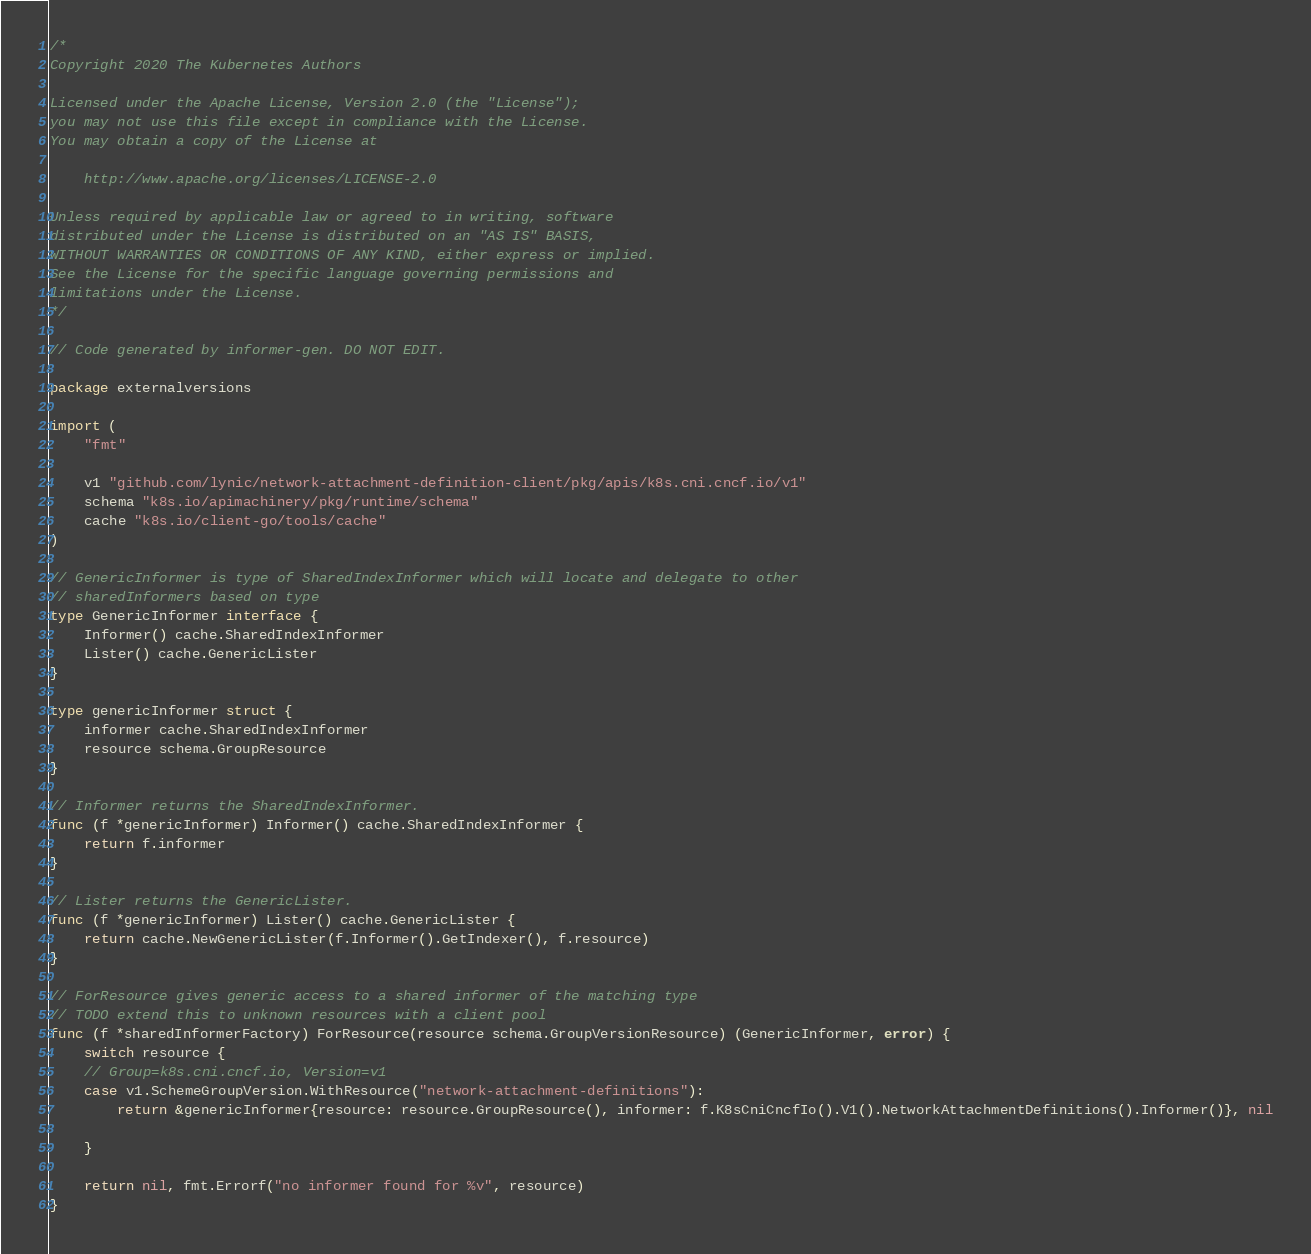Convert code to text. <code><loc_0><loc_0><loc_500><loc_500><_Go_>/*
Copyright 2020 The Kubernetes Authors

Licensed under the Apache License, Version 2.0 (the "License");
you may not use this file except in compliance with the License.
You may obtain a copy of the License at

    http://www.apache.org/licenses/LICENSE-2.0

Unless required by applicable law or agreed to in writing, software
distributed under the License is distributed on an "AS IS" BASIS,
WITHOUT WARRANTIES OR CONDITIONS OF ANY KIND, either express or implied.
See the License for the specific language governing permissions and
limitations under the License.
*/

// Code generated by informer-gen. DO NOT EDIT.

package externalversions

import (
	"fmt"

	v1 "github.com/lynic/network-attachment-definition-client/pkg/apis/k8s.cni.cncf.io/v1"
	schema "k8s.io/apimachinery/pkg/runtime/schema"
	cache "k8s.io/client-go/tools/cache"
)

// GenericInformer is type of SharedIndexInformer which will locate and delegate to other
// sharedInformers based on type
type GenericInformer interface {
	Informer() cache.SharedIndexInformer
	Lister() cache.GenericLister
}

type genericInformer struct {
	informer cache.SharedIndexInformer
	resource schema.GroupResource
}

// Informer returns the SharedIndexInformer.
func (f *genericInformer) Informer() cache.SharedIndexInformer {
	return f.informer
}

// Lister returns the GenericLister.
func (f *genericInformer) Lister() cache.GenericLister {
	return cache.NewGenericLister(f.Informer().GetIndexer(), f.resource)
}

// ForResource gives generic access to a shared informer of the matching type
// TODO extend this to unknown resources with a client pool
func (f *sharedInformerFactory) ForResource(resource schema.GroupVersionResource) (GenericInformer, error) {
	switch resource {
	// Group=k8s.cni.cncf.io, Version=v1
	case v1.SchemeGroupVersion.WithResource("network-attachment-definitions"):
		return &genericInformer{resource: resource.GroupResource(), informer: f.K8sCniCncfIo().V1().NetworkAttachmentDefinitions().Informer()}, nil

	}

	return nil, fmt.Errorf("no informer found for %v", resource)
}
</code> 